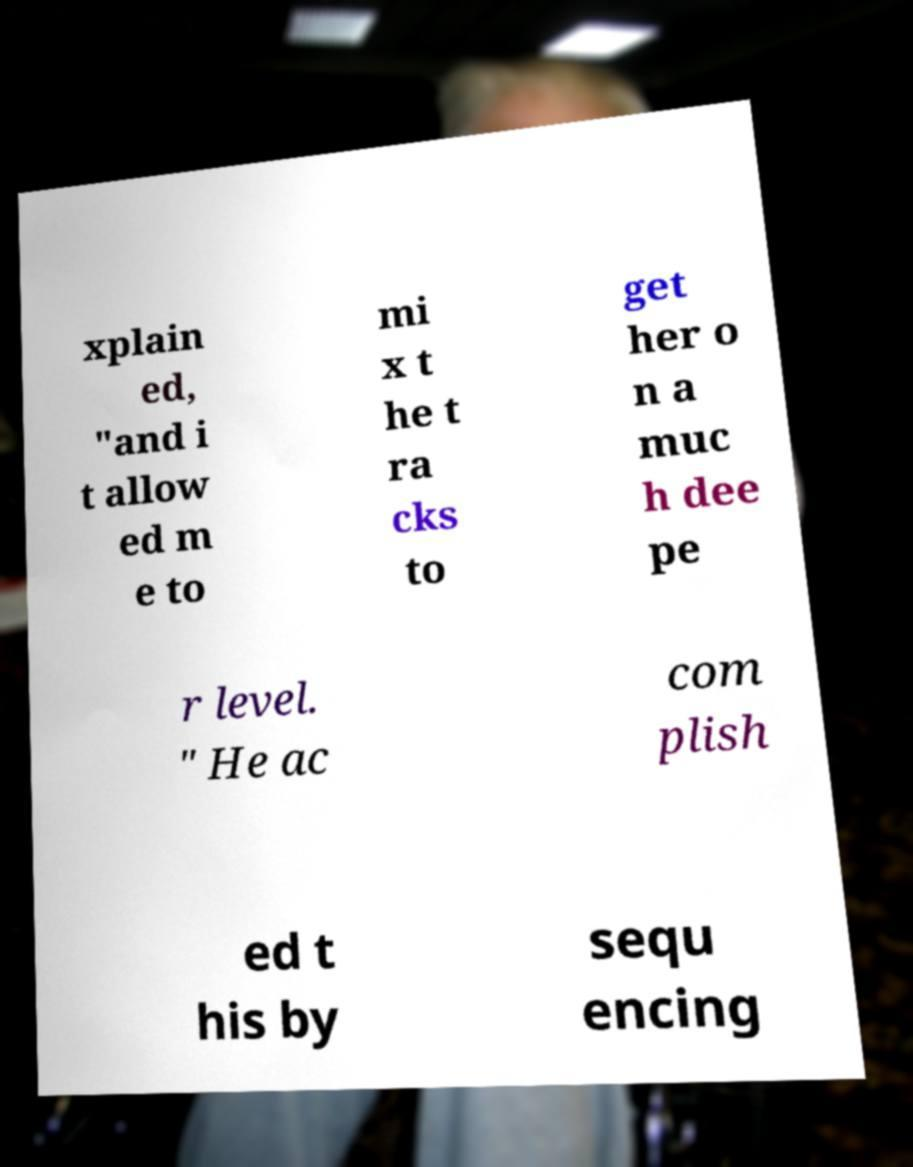Can you accurately transcribe the text from the provided image for me? xplain ed, "and i t allow ed m e to mi x t he t ra cks to get her o n a muc h dee pe r level. " He ac com plish ed t his by sequ encing 